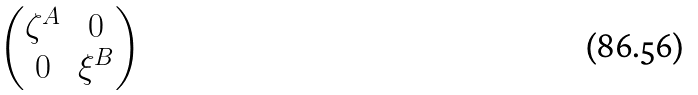<formula> <loc_0><loc_0><loc_500><loc_500>\begin{pmatrix} \zeta ^ { A } & 0 \\ 0 & \xi ^ { B } \end{pmatrix}</formula> 